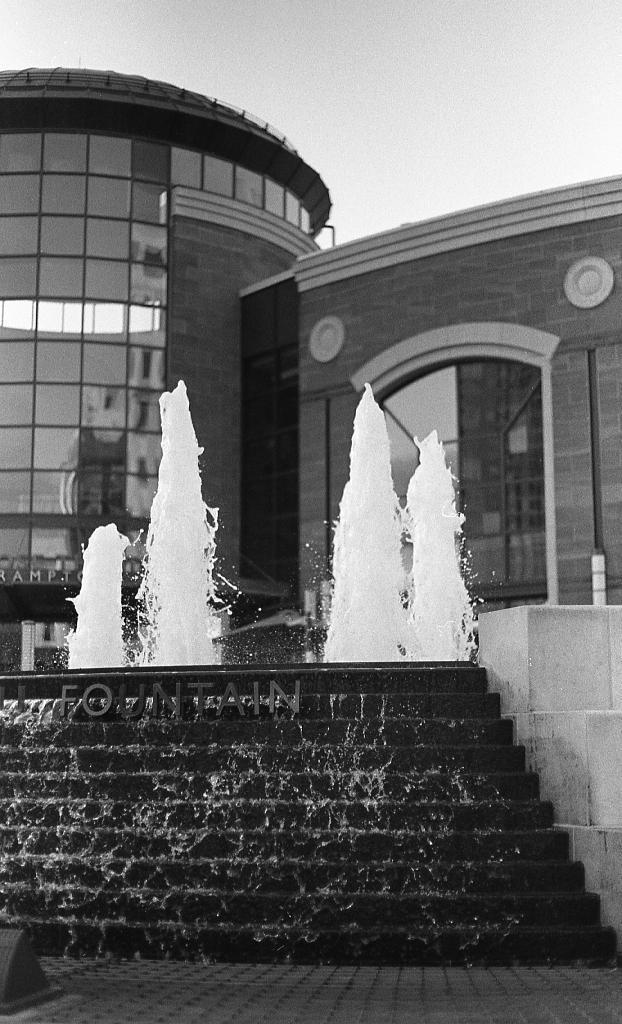Describe this image in one or two sentences. In the image we can see there is a fountain and water is flowing down from the stairs near the fountain. Behind there are buildings and there is a clear sky. The image is in black and white colour. 